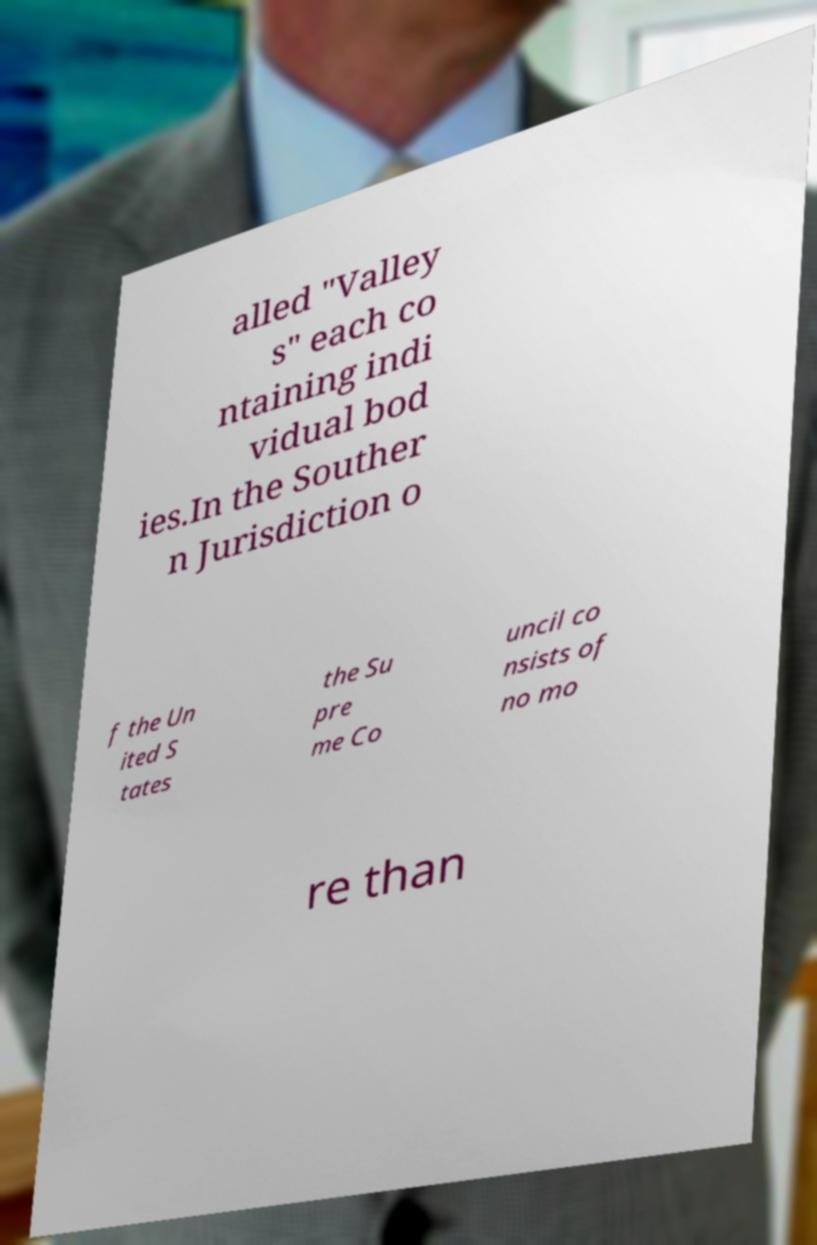What messages or text are displayed in this image? I need them in a readable, typed format. alled "Valley s" each co ntaining indi vidual bod ies.In the Souther n Jurisdiction o f the Un ited S tates the Su pre me Co uncil co nsists of no mo re than 